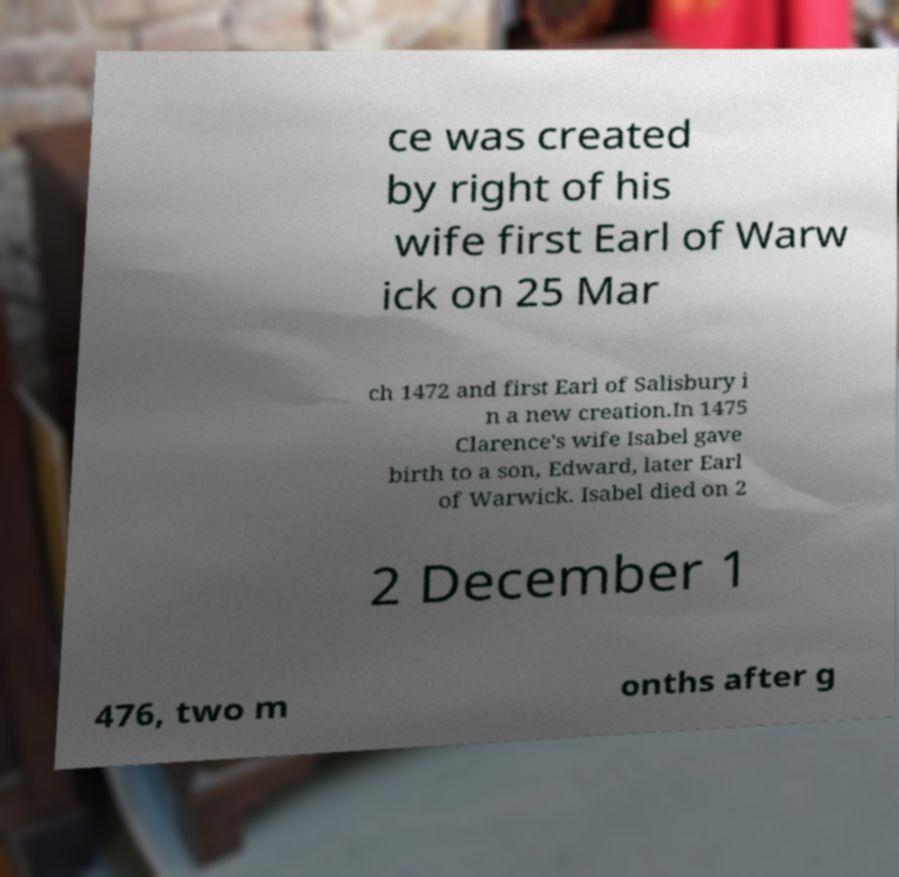Can you read and provide the text displayed in the image?This photo seems to have some interesting text. Can you extract and type it out for me? ce was created by right of his wife first Earl of Warw ick on 25 Mar ch 1472 and first Earl of Salisbury i n a new creation.In 1475 Clarence's wife Isabel gave birth to a son, Edward, later Earl of Warwick. Isabel died on 2 2 December 1 476, two m onths after g 